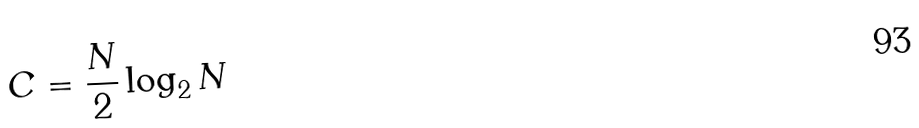<formula> <loc_0><loc_0><loc_500><loc_500>C = \frac { N } { 2 } \log _ { 2 } N</formula> 